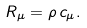<formula> <loc_0><loc_0><loc_500><loc_500>R _ { \mu } = { \rho } \, { c _ { \mu } } .</formula> 